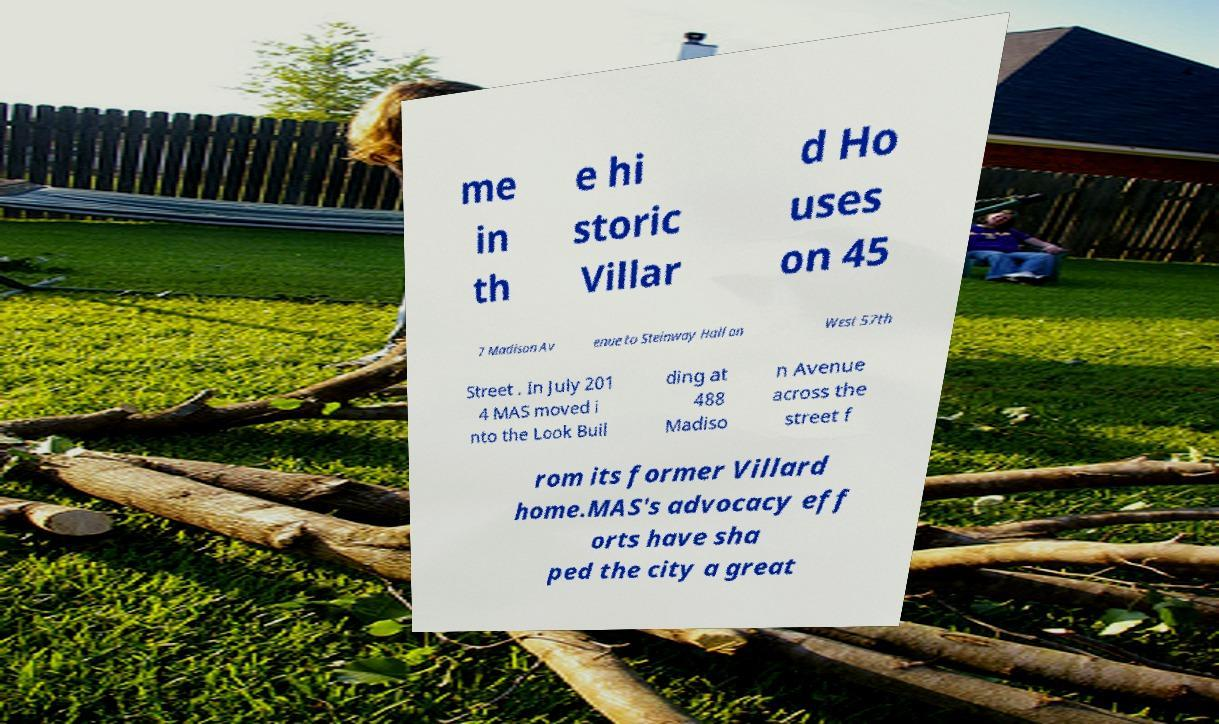Please identify and transcribe the text found in this image. me in th e hi storic Villar d Ho uses on 45 7 Madison Av enue to Steinway Hall on West 57th Street . In July 201 4 MAS moved i nto the Look Buil ding at 488 Madiso n Avenue across the street f rom its former Villard home.MAS's advocacy eff orts have sha ped the city a great 